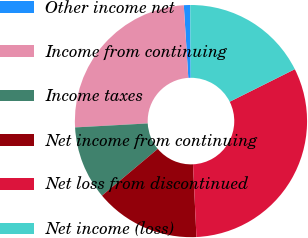Convert chart to OTSL. <chart><loc_0><loc_0><loc_500><loc_500><pie_chart><fcel>Other income net<fcel>Income from continuing<fcel>Income taxes<fcel>Net income from continuing<fcel>Net loss from discontinued<fcel>Net income (loss)<nl><fcel>0.89%<fcel>24.88%<fcel>10.23%<fcel>14.65%<fcel>31.62%<fcel>17.72%<nl></chart> 